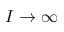Convert formula to latex. <formula><loc_0><loc_0><loc_500><loc_500>I \to \infty</formula> 